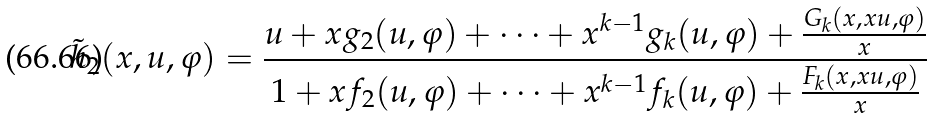Convert formula to latex. <formula><loc_0><loc_0><loc_500><loc_500>\tilde { h } _ { 2 } ( x , u , \varphi ) = \frac { u + x g _ { 2 } ( u , \varphi ) + \cdots + x ^ { k - 1 } g _ { k } ( u , \varphi ) + \frac { G _ { k } ( x , x u , \varphi ) } { x } } { 1 + x f _ { 2 } ( u , \varphi ) + \cdots + x ^ { k - 1 } f _ { k } ( u , \varphi ) + \frac { F _ { k } ( x , x u , \varphi ) } { x } }</formula> 